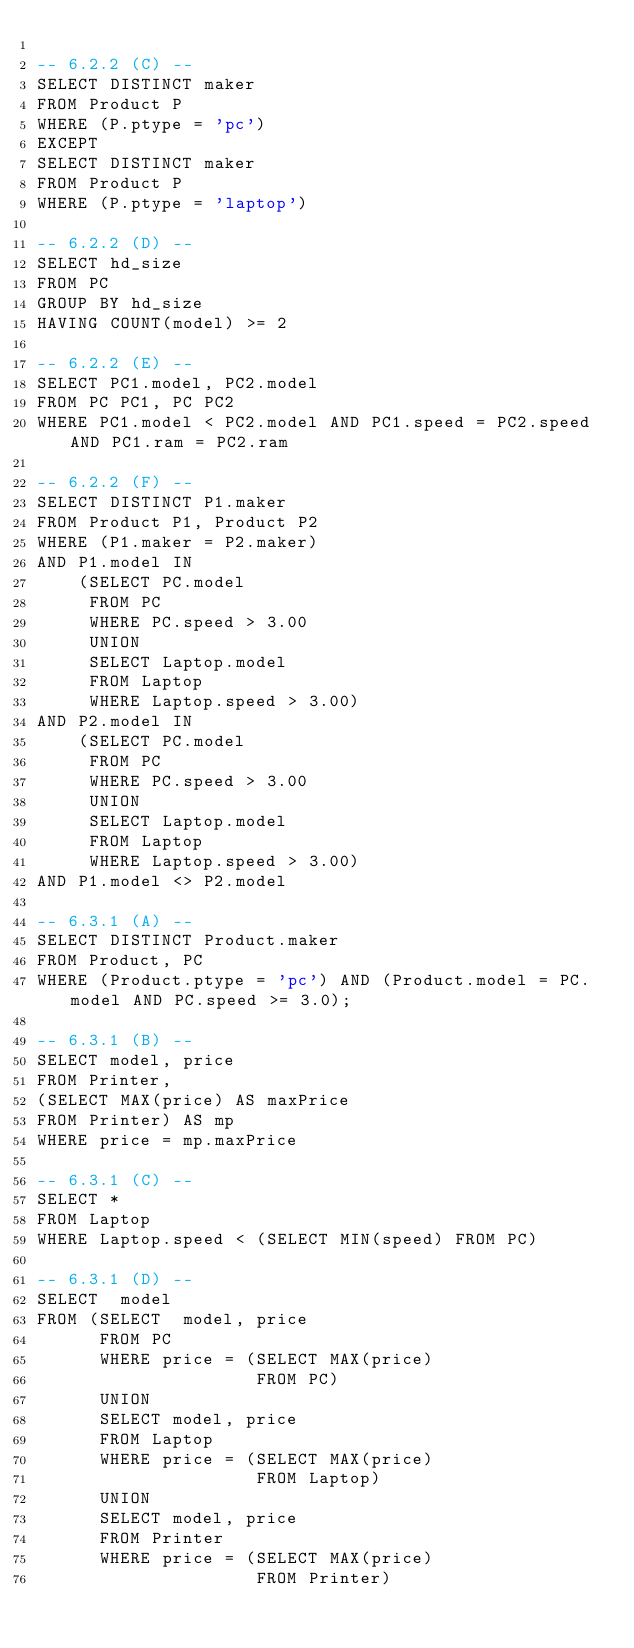Convert code to text. <code><loc_0><loc_0><loc_500><loc_500><_SQL_>
-- 6.2.2 (C) --
SELECT DISTINCT maker
FROM Product P
WHERE (P.ptype = 'pc')
EXCEPT
SELECT DISTINCT maker
FROM Product P
WHERE (P.ptype = 'laptop')

-- 6.2.2 (D) --
SELECT hd_size
FROM PC
GROUP BY hd_size
HAVING COUNT(model) >= 2

-- 6.2.2 (E) --
SELECT PC1.model, PC2.model
FROM PC PC1, PC PC2
WHERE PC1.model < PC2.model AND PC1.speed = PC2.speed AND PC1.ram = PC2.ram

-- 6.2.2 (F) --
SELECT DISTINCT P1.maker
FROM Product P1, Product P2
WHERE (P1.maker = P2.maker)
AND P1.model IN 
	(SELECT PC.model
	 FROM PC
	 WHERE PC.speed > 3.00
	 UNION
	 SELECT Laptop.model
	 FROM Laptop
     WHERE Laptop.speed > 3.00)
AND P2.model IN 
	(SELECT PC.model
	 FROM PC
	 WHERE PC.speed > 3.00
	 UNION
	 SELECT Laptop.model
	 FROM Laptop
	 WHERE Laptop.speed > 3.00)
AND P1.model <> P2.model

-- 6.3.1 (A) --
SELECT DISTINCT Product.maker
FROM Product, PC
WHERE (Product.ptype = 'pc') AND (Product.model = PC.model AND PC.speed >= 3.0);

-- 6.3.1 (B) --
SELECT model, price 
FROM Printer, 
(SELECT MAX(price) AS maxPrice  
FROM Printer) AS mp 
WHERE price = mp.maxPrice

-- 6.3.1 (C) --
SELECT *
FROM Laptop 
WHERE Laptop.speed < (SELECT MIN(speed) FROM PC)

-- 6.3.1 (D) --
SELECT  model 
FROM (SELECT  model, price 
      FROM PC
      WHERE price = (SELECT MAX(price) 
                     FROM PC)
      UNION
      SELECT model, price 
      FROM Laptop
      WHERE price = (SELECT MAX(price) 
                     FROM Laptop)
      UNION
      SELECT model, price 
      FROM Printer
      WHERE price = (SELECT MAX(price) 
                     FROM Printer)</code> 